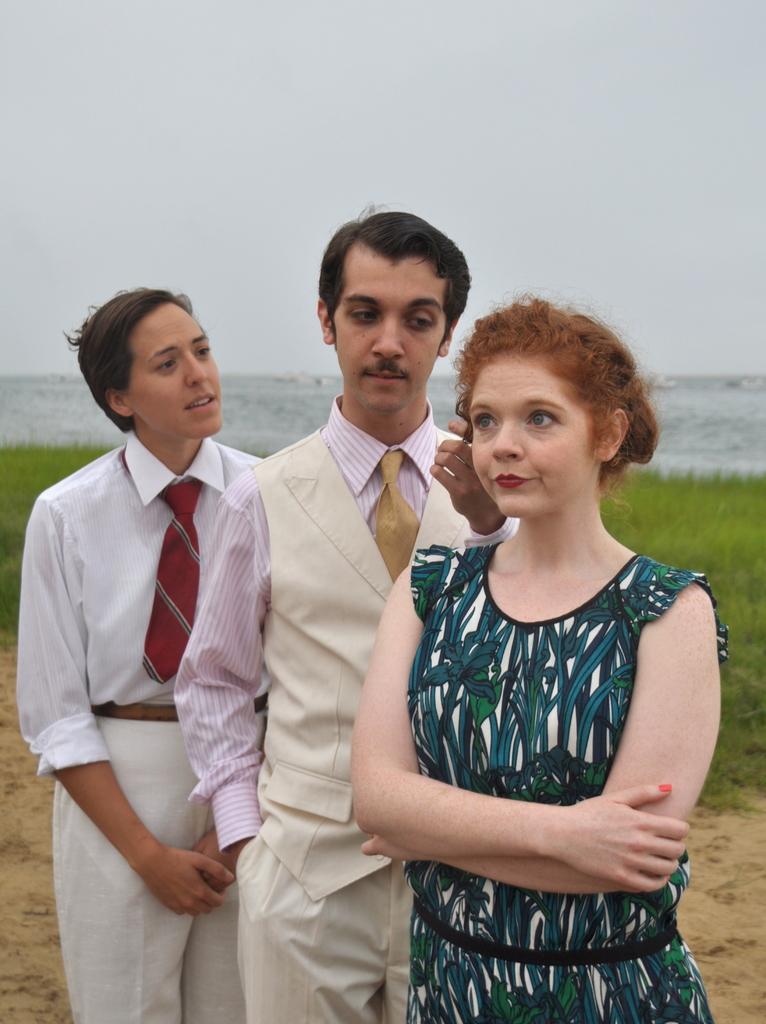Could you give a brief overview of what you see in this image? In this picture we can see three people, they are standing, in the background we can see grass and water. 